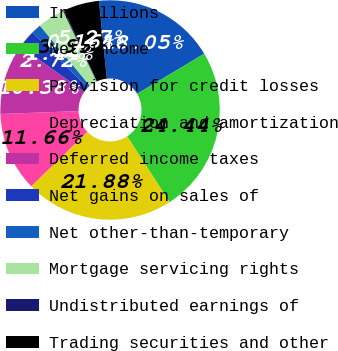<chart> <loc_0><loc_0><loc_500><loc_500><pie_chart><fcel>In millions<fcel>Net income<fcel>Provision for credit losses<fcel>Depreciation and amortization<fcel>Deferred income taxes<fcel>Net gains on sales of<fcel>Net other-than-temporary<fcel>Mortgage servicing rights<fcel>Undistributed earnings of<fcel>Trading securities and other<nl><fcel>18.05%<fcel>24.44%<fcel>21.88%<fcel>11.66%<fcel>10.38%<fcel>2.72%<fcel>1.44%<fcel>3.99%<fcel>0.16%<fcel>5.27%<nl></chart> 